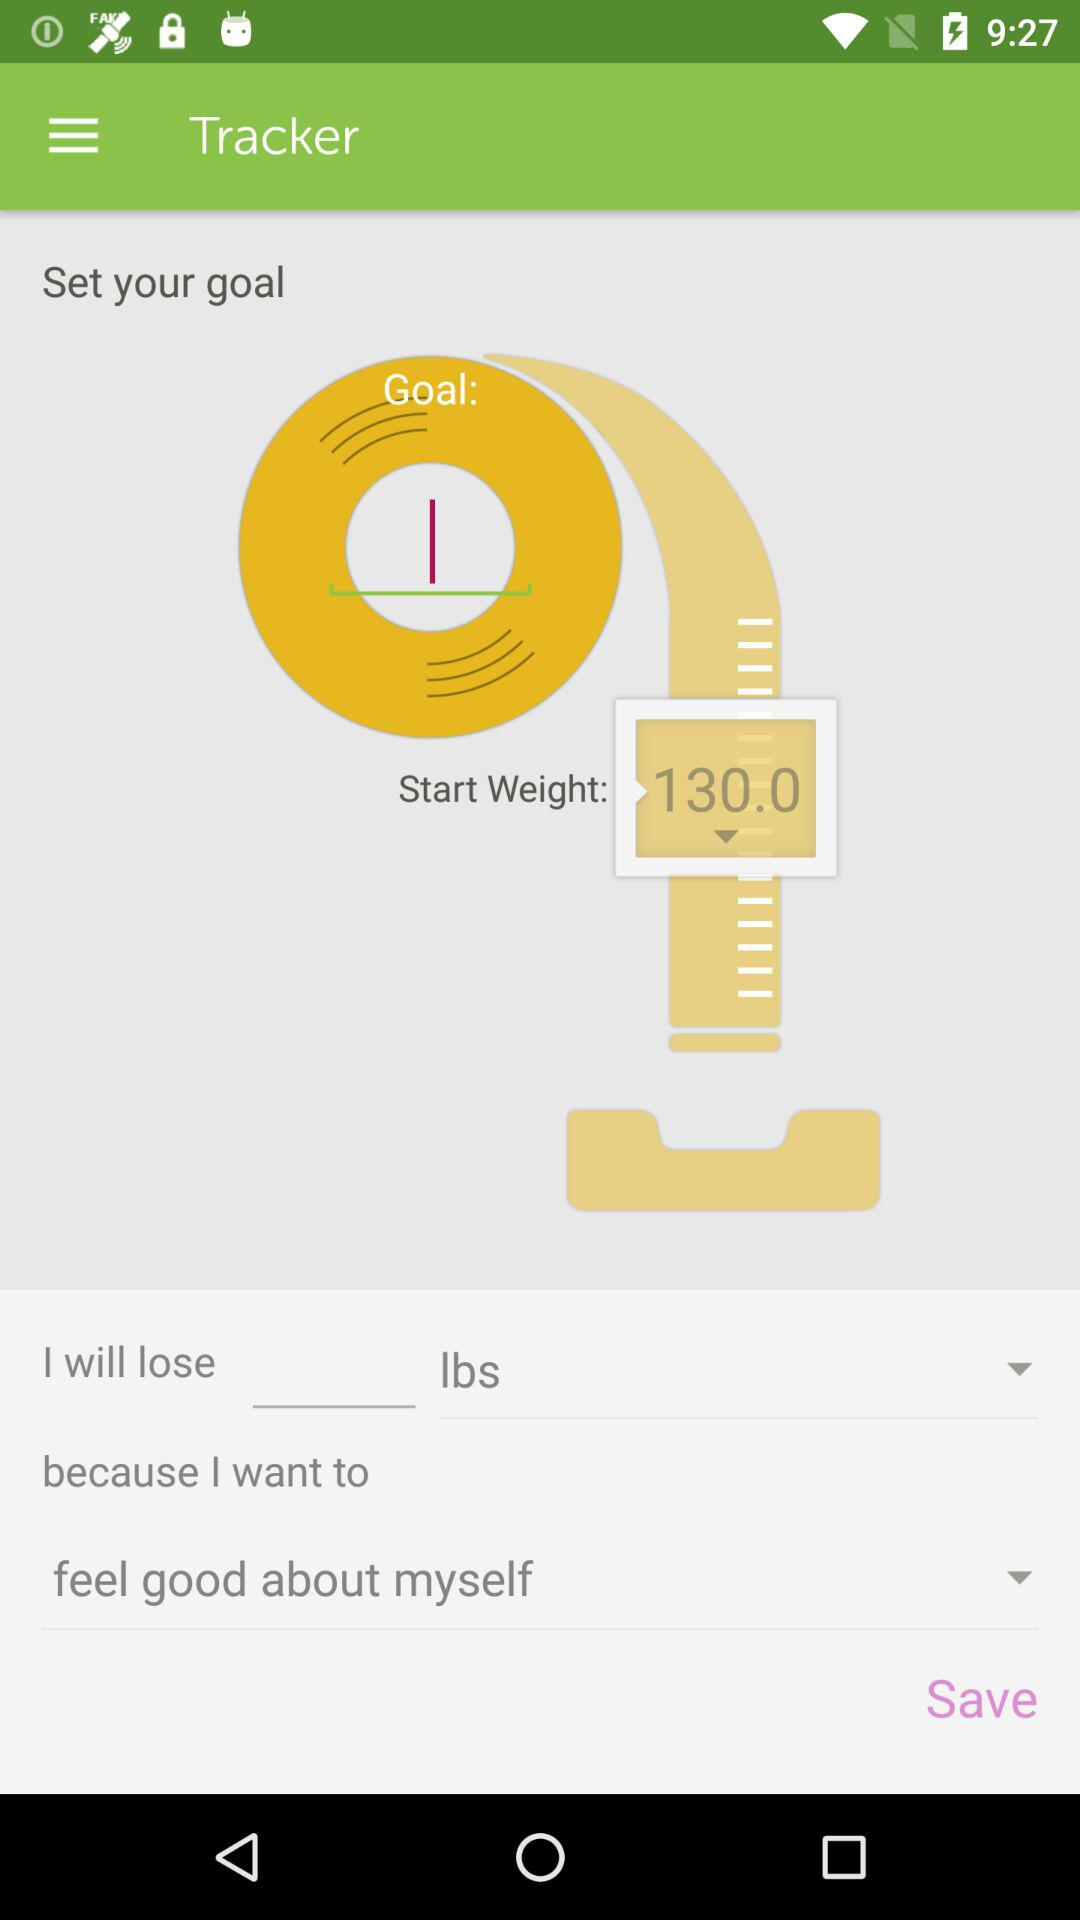Which is the preferred weight unit? The preferred weight unit is "lbs". 